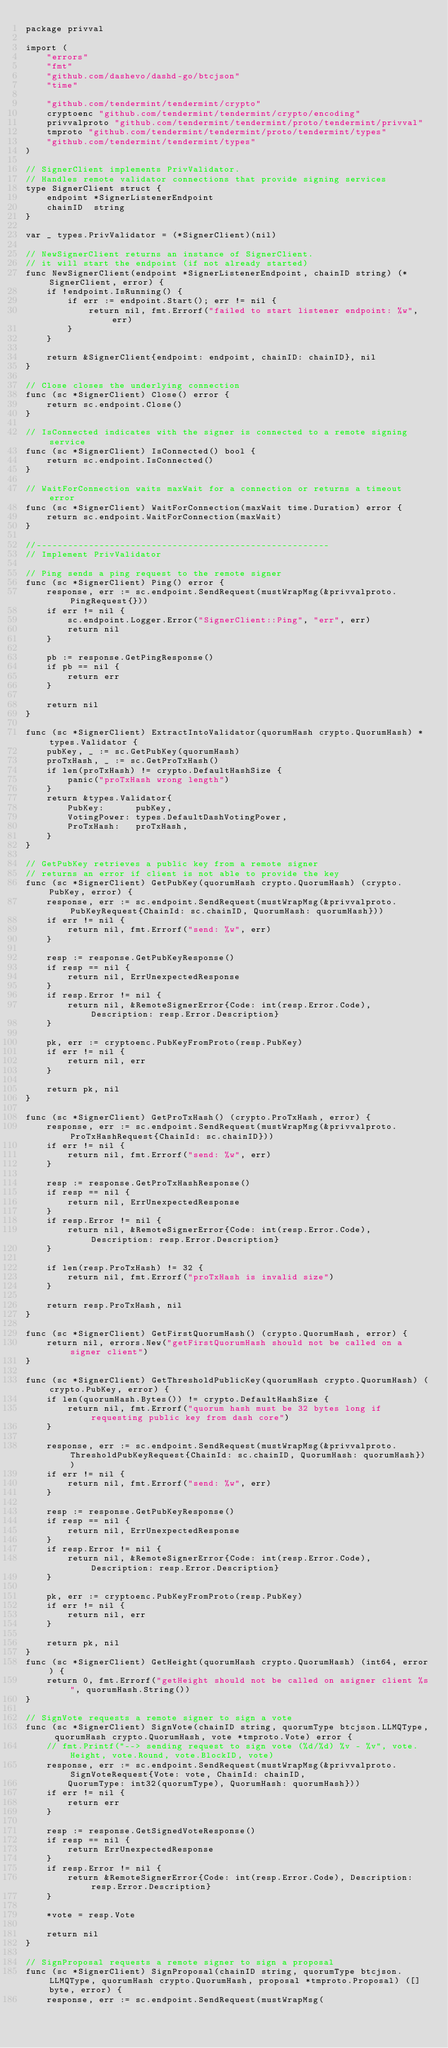Convert code to text. <code><loc_0><loc_0><loc_500><loc_500><_Go_>package privval

import (
	"errors"
	"fmt"
	"github.com/dashevo/dashd-go/btcjson"
	"time"

	"github.com/tendermint/tendermint/crypto"
	cryptoenc "github.com/tendermint/tendermint/crypto/encoding"
	privvalproto "github.com/tendermint/tendermint/proto/tendermint/privval"
	tmproto "github.com/tendermint/tendermint/proto/tendermint/types"
	"github.com/tendermint/tendermint/types"
)

// SignerClient implements PrivValidator.
// Handles remote validator connections that provide signing services
type SignerClient struct {
	endpoint *SignerListenerEndpoint
	chainID  string
}

var _ types.PrivValidator = (*SignerClient)(nil)

// NewSignerClient returns an instance of SignerClient.
// it will start the endpoint (if not already started)
func NewSignerClient(endpoint *SignerListenerEndpoint, chainID string) (*SignerClient, error) {
	if !endpoint.IsRunning() {
		if err := endpoint.Start(); err != nil {
			return nil, fmt.Errorf("failed to start listener endpoint: %w", err)
		}
	}

	return &SignerClient{endpoint: endpoint, chainID: chainID}, nil
}

// Close closes the underlying connection
func (sc *SignerClient) Close() error {
	return sc.endpoint.Close()
}

// IsConnected indicates with the signer is connected to a remote signing service
func (sc *SignerClient) IsConnected() bool {
	return sc.endpoint.IsConnected()
}

// WaitForConnection waits maxWait for a connection or returns a timeout error
func (sc *SignerClient) WaitForConnection(maxWait time.Duration) error {
	return sc.endpoint.WaitForConnection(maxWait)
}

//--------------------------------------------------------
// Implement PrivValidator

// Ping sends a ping request to the remote signer
func (sc *SignerClient) Ping() error {
	response, err := sc.endpoint.SendRequest(mustWrapMsg(&privvalproto.PingRequest{}))
	if err != nil {
		sc.endpoint.Logger.Error("SignerClient::Ping", "err", err)
		return nil
	}

	pb := response.GetPingResponse()
	if pb == nil {
		return err
	}

	return nil
}

func (sc *SignerClient) ExtractIntoValidator(quorumHash crypto.QuorumHash) *types.Validator {
	pubKey, _ := sc.GetPubKey(quorumHash)
	proTxHash, _ := sc.GetProTxHash()
	if len(proTxHash) != crypto.DefaultHashSize {
		panic("proTxHash wrong length")
	}
	return &types.Validator{
		PubKey:      pubKey,
		VotingPower: types.DefaultDashVotingPower,
		ProTxHash:   proTxHash,
	}
}

// GetPubKey retrieves a public key from a remote signer
// returns an error if client is not able to provide the key
func (sc *SignerClient) GetPubKey(quorumHash crypto.QuorumHash) (crypto.PubKey, error) {
	response, err := sc.endpoint.SendRequest(mustWrapMsg(&privvalproto.PubKeyRequest{ChainId: sc.chainID, QuorumHash: quorumHash}))
	if err != nil {
		return nil, fmt.Errorf("send: %w", err)
	}

	resp := response.GetPubKeyResponse()
	if resp == nil {
		return nil, ErrUnexpectedResponse
	}
	if resp.Error != nil {
		return nil, &RemoteSignerError{Code: int(resp.Error.Code), Description: resp.Error.Description}
	}

	pk, err := cryptoenc.PubKeyFromProto(resp.PubKey)
	if err != nil {
		return nil, err
	}

	return pk, nil
}

func (sc *SignerClient) GetProTxHash() (crypto.ProTxHash, error) {
	response, err := sc.endpoint.SendRequest(mustWrapMsg(&privvalproto.ProTxHashRequest{ChainId: sc.chainID}))
	if err != nil {
		return nil, fmt.Errorf("send: %w", err)
	}

	resp := response.GetProTxHashResponse()
	if resp == nil {
		return nil, ErrUnexpectedResponse
	}
	if resp.Error != nil {
		return nil, &RemoteSignerError{Code: int(resp.Error.Code), Description: resp.Error.Description}
	}

	if len(resp.ProTxHash) != 32 {
		return nil, fmt.Errorf("proTxHash is invalid size")
	}

	return resp.ProTxHash, nil
}

func (sc *SignerClient) GetFirstQuorumHash() (crypto.QuorumHash, error) {
	return nil, errors.New("getFirstQuorumHash should not be called on a signer client")
}

func (sc *SignerClient) GetThresholdPublicKey(quorumHash crypto.QuorumHash) (crypto.PubKey, error) {
	if len(quorumHash.Bytes()) != crypto.DefaultHashSize {
		return nil, fmt.Errorf("quorum hash must be 32 bytes long if requesting public key from dash core")
	}

	response, err := sc.endpoint.SendRequest(mustWrapMsg(&privvalproto.ThresholdPubKeyRequest{ChainId: sc.chainID, QuorumHash: quorumHash}))
	if err != nil {
		return nil, fmt.Errorf("send: %w", err)
	}

	resp := response.GetPubKeyResponse()
	if resp == nil {
		return nil, ErrUnexpectedResponse
	}
	if resp.Error != nil {
		return nil, &RemoteSignerError{Code: int(resp.Error.Code), Description: resp.Error.Description}
	}

	pk, err := cryptoenc.PubKeyFromProto(resp.PubKey)
	if err != nil {
		return nil, err
	}

	return pk, nil
}
func (sc *SignerClient) GetHeight(quorumHash crypto.QuorumHash) (int64, error) {
	return 0, fmt.Errorf("getHeight should not be called on asigner client %s", quorumHash.String())
}

// SignVote requests a remote signer to sign a vote
func (sc *SignerClient) SignVote(chainID string, quorumType btcjson.LLMQType, quorumHash crypto.QuorumHash, vote *tmproto.Vote) error {
	// fmt.Printf("--> sending request to sign vote (%d/%d) %v - %v", vote.Height, vote.Round, vote.BlockID, vote)
	response, err := sc.endpoint.SendRequest(mustWrapMsg(&privvalproto.SignVoteRequest{Vote: vote, ChainId: chainID,
		QuorumType: int32(quorumType), QuorumHash: quorumHash}))
	if err != nil {
		return err
	}

	resp := response.GetSignedVoteResponse()
	if resp == nil {
		return ErrUnexpectedResponse
	}
	if resp.Error != nil {
		return &RemoteSignerError{Code: int(resp.Error.Code), Description: resp.Error.Description}
	}

	*vote = resp.Vote

	return nil
}

// SignProposal requests a remote signer to sign a proposal
func (sc *SignerClient) SignProposal(chainID string, quorumType btcjson.LLMQType, quorumHash crypto.QuorumHash, proposal *tmproto.Proposal) ([]byte, error) {
	response, err := sc.endpoint.SendRequest(mustWrapMsg(</code> 